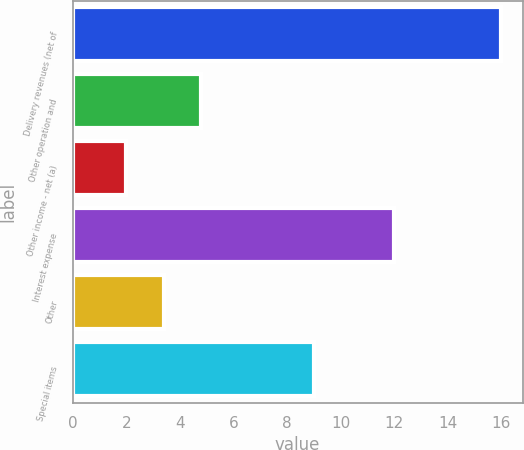<chart> <loc_0><loc_0><loc_500><loc_500><bar_chart><fcel>Delivery revenues (net of<fcel>Other operation and<fcel>Other income - net (a)<fcel>Interest expense<fcel>Other<fcel>Special items<nl><fcel>16<fcel>4.8<fcel>2<fcel>12<fcel>3.4<fcel>9<nl></chart> 